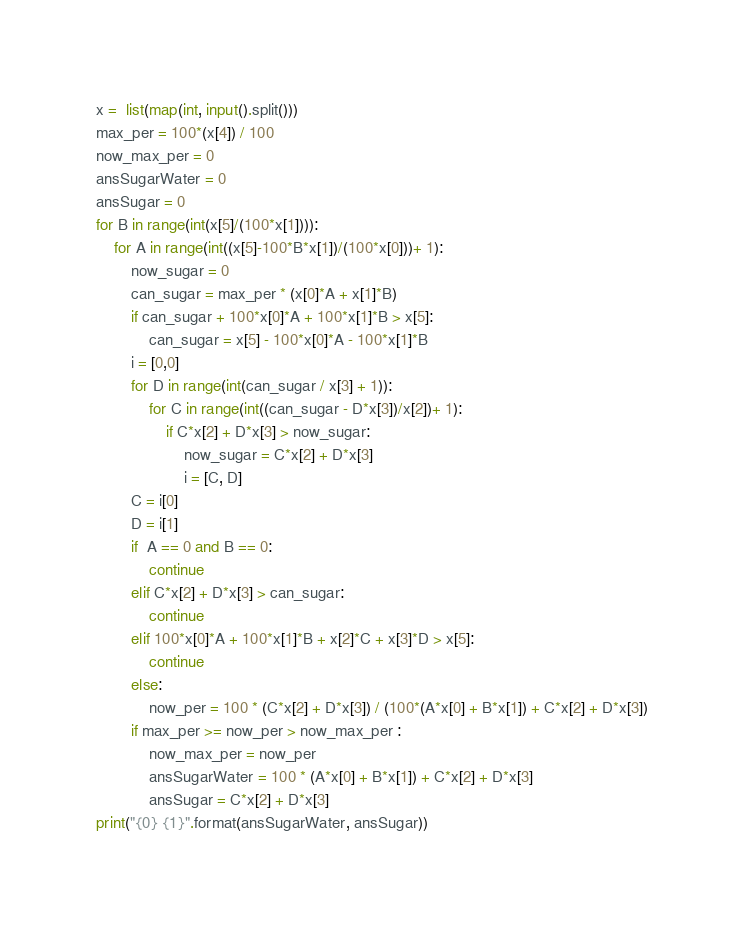<code> <loc_0><loc_0><loc_500><loc_500><_Python_>x =  list(map(int, input().split()))
max_per = 100*(x[4]) / 100
now_max_per = 0
ansSugarWater = 0
ansSugar = 0
for B in range(int(x[5]/(100*x[1]))):
    for A in range(int((x[5]-100*B*x[1])/(100*x[0]))+ 1):
        now_sugar = 0
        can_sugar = max_per * (x[0]*A + x[1]*B)
        if can_sugar + 100*x[0]*A + 100*x[1]*B > x[5]:
            can_sugar = x[5] - 100*x[0]*A - 100*x[1]*B
        i = [0,0]
        for D in range(int(can_sugar / x[3] + 1)):
            for C in range(int((can_sugar - D*x[3])/x[2])+ 1):
                if C*x[2] + D*x[3] > now_sugar:
                    now_sugar = C*x[2] + D*x[3]
                    i = [C, D]
        C = i[0]
        D = i[1]
        if  A == 0 and B == 0:
            continue
        elif C*x[2] + D*x[3] > can_sugar:
            continue
        elif 100*x[0]*A + 100*x[1]*B + x[2]*C + x[3]*D > x[5]:
            continue
        else:
            now_per = 100 * (C*x[2] + D*x[3]) / (100*(A*x[0] + B*x[1]) + C*x[2] + D*x[3])
        if max_per >= now_per > now_max_per :
            now_max_per = now_per
            ansSugarWater = 100 * (A*x[0] + B*x[1]) + C*x[2] + D*x[3]
            ansSugar = C*x[2] + D*x[3]
print("{0} {1}".format(ansSugarWater, ansSugar))
</code> 